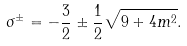Convert formula to latex. <formula><loc_0><loc_0><loc_500><loc_500>\sigma ^ { \pm } = - \frac { 3 } { 2 } \pm \frac { 1 } { 2 } \sqrt { 9 + 4 m ^ { 2 } } .</formula> 